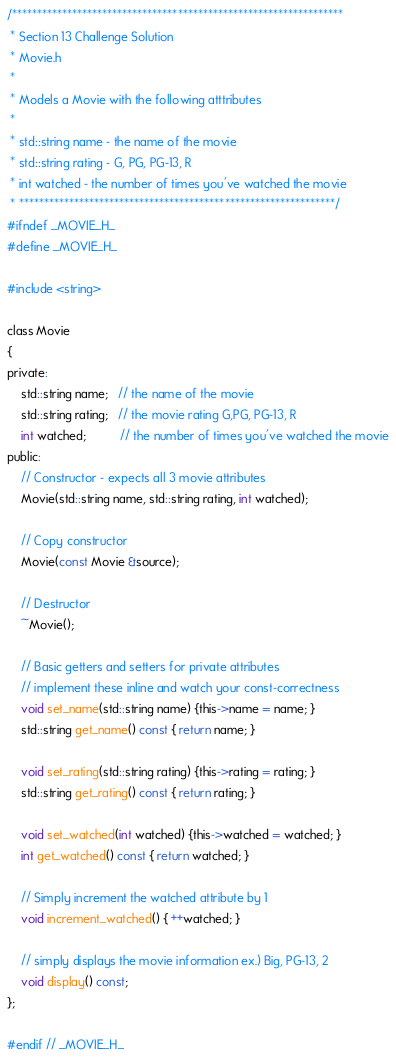<code> <loc_0><loc_0><loc_500><loc_500><_C_>/******************************************************************
 * Section 13 Challenge Solution
 * Movie.h
 * 
 * Models a Movie with the following atttributes
 * 
 * std::string name - the name of the movie 
 * std::string rating - G, PG, PG-13, R
 * int watched - the number of times you've watched the movie
 * ***************************************************************/
#ifndef _MOVIE_H_
#define _MOVIE_H_

#include <string>

class Movie
{
private:
    std::string name;   // the name of the movie
    std::string rating;   // the movie rating G,PG, PG-13, R
    int watched;          // the number of times you've watched the movie
public:
    // Constructor - expects all 3 movie attributes
    Movie(std::string name, std::string rating, int watched);
    
    // Copy constructor 
    Movie(const Movie &source); 
    
    // Destructor
    ~Movie();
    
    // Basic getters and setters for private attributes
    // implement these inline and watch your const-correctness
    void set_name(std::string name) {this->name = name; }
    std::string get_name() const { return name; }
    
    void set_rating(std::string rating) {this->rating = rating; }
    std::string get_rating() const { return rating; }
    
    void set_watched(int watched) {this->watched = watched; }
    int get_watched() const { return watched; }
    
    // Simply increment the watched attribute by 1
    void increment_watched() { ++watched; }
    
    // simply displays the movie information ex.) Big, PG-13, 2
    void display() const;
};

#endif // _MOVIE_H_
</code> 